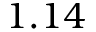Convert formula to latex. <formula><loc_0><loc_0><loc_500><loc_500>1 . 1 4</formula> 